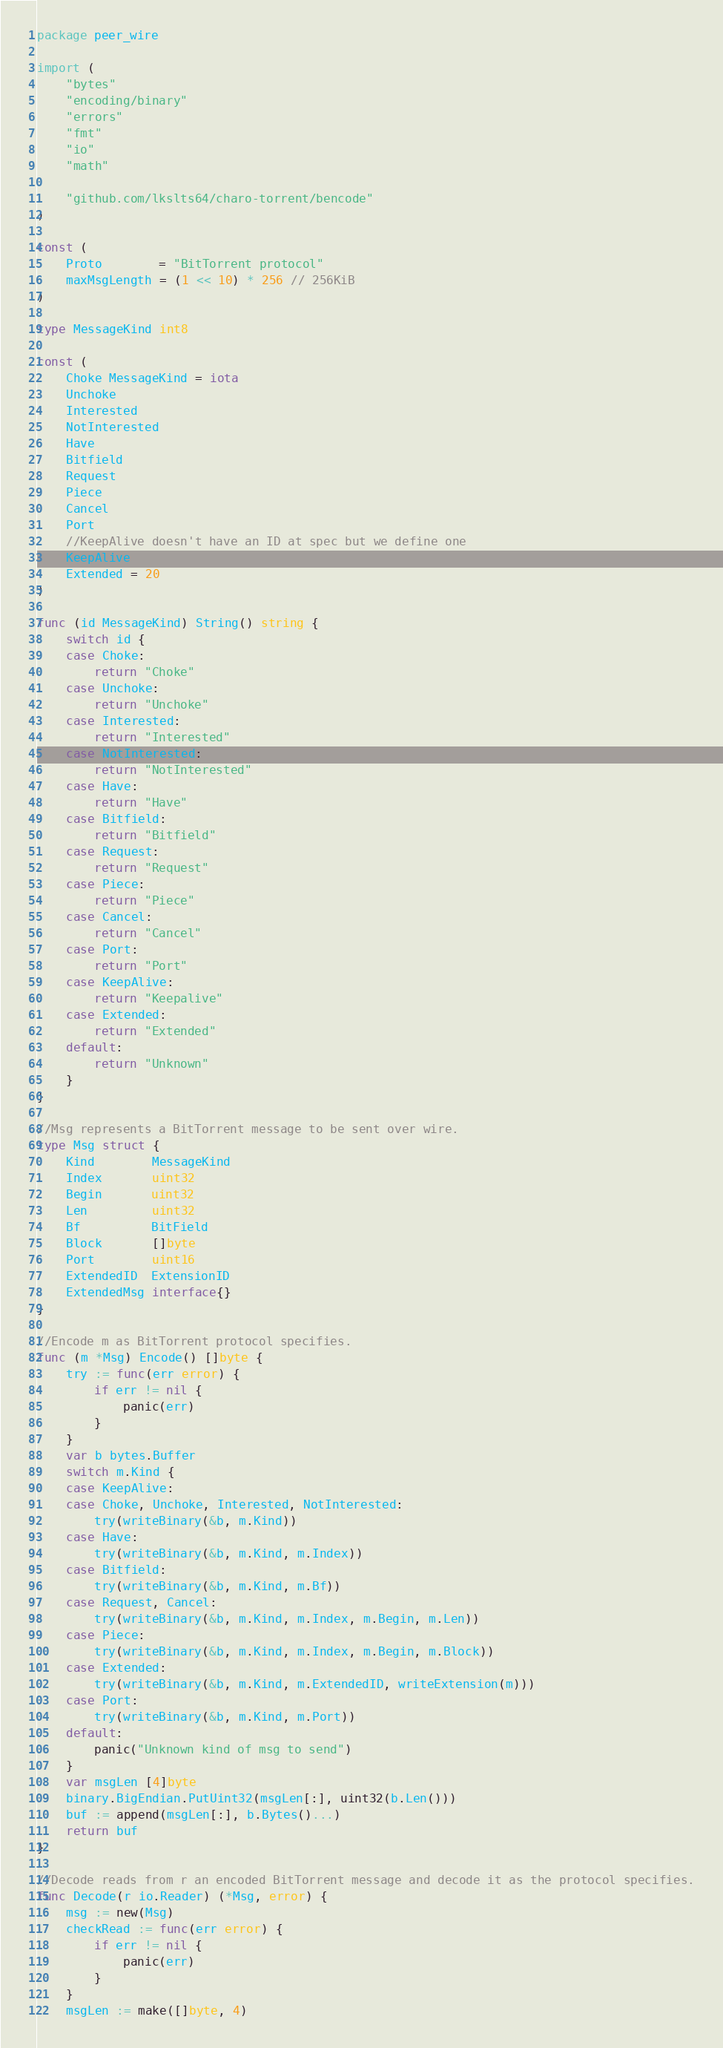<code> <loc_0><loc_0><loc_500><loc_500><_Go_>package peer_wire

import (
	"bytes"
	"encoding/binary"
	"errors"
	"fmt"
	"io"
	"math"

	"github.com/lkslts64/charo-torrent/bencode"
)

const (
	Proto        = "BitTorrent protocol"
	maxMsgLength = (1 << 10) * 256 // 256KiB
)

type MessageKind int8

const (
	Choke MessageKind = iota
	Unchoke
	Interested
	NotInterested
	Have
	Bitfield
	Request
	Piece
	Cancel
	Port
	//KeepAlive doesn't have an ID at spec but we define one
	KeepAlive
	Extended = 20
)

func (id MessageKind) String() string {
	switch id {
	case Choke:
		return "Choke"
	case Unchoke:
		return "Unchoke"
	case Interested:
		return "Interested"
	case NotInterested:
		return "NotInterested"
	case Have:
		return "Have"
	case Bitfield:
		return "Bitfield"
	case Request:
		return "Request"
	case Piece:
		return "Piece"
	case Cancel:
		return "Cancel"
	case Port:
		return "Port"
	case KeepAlive:
		return "Keepalive"
	case Extended:
		return "Extended"
	default:
		return "Unknown"
	}
}

//Msg represents a BitTorrent message to be sent over wire.
type Msg struct {
	Kind        MessageKind
	Index       uint32
	Begin       uint32
	Len         uint32
	Bf          BitField
	Block       []byte
	Port        uint16
	ExtendedID  ExtensionID
	ExtendedMsg interface{}
}

//Encode m as BitTorrent protocol specifies.
func (m *Msg) Encode() []byte {
	try := func(err error) {
		if err != nil {
			panic(err)
		}
	}
	var b bytes.Buffer
	switch m.Kind {
	case KeepAlive:
	case Choke, Unchoke, Interested, NotInterested:
		try(writeBinary(&b, m.Kind))
	case Have:
		try(writeBinary(&b, m.Kind, m.Index))
	case Bitfield:
		try(writeBinary(&b, m.Kind, m.Bf))
	case Request, Cancel:
		try(writeBinary(&b, m.Kind, m.Index, m.Begin, m.Len))
	case Piece:
		try(writeBinary(&b, m.Kind, m.Index, m.Begin, m.Block))
	case Extended:
		try(writeBinary(&b, m.Kind, m.ExtendedID, writeExtension(m)))
	case Port:
		try(writeBinary(&b, m.Kind, m.Port))
	default:
		panic("Unknown kind of msg to send")
	}
	var msgLen [4]byte
	binary.BigEndian.PutUint32(msgLen[:], uint32(b.Len()))
	buf := append(msgLen[:], b.Bytes()...)
	return buf
}

//Decode reads from r an encoded BitTorrent message and decode it as the protocol specifies.
func Decode(r io.Reader) (*Msg, error) {
	msg := new(Msg)
	checkRead := func(err error) {
		if err != nil {
			panic(err)
		}
	}
	msgLen := make([]byte, 4)</code> 